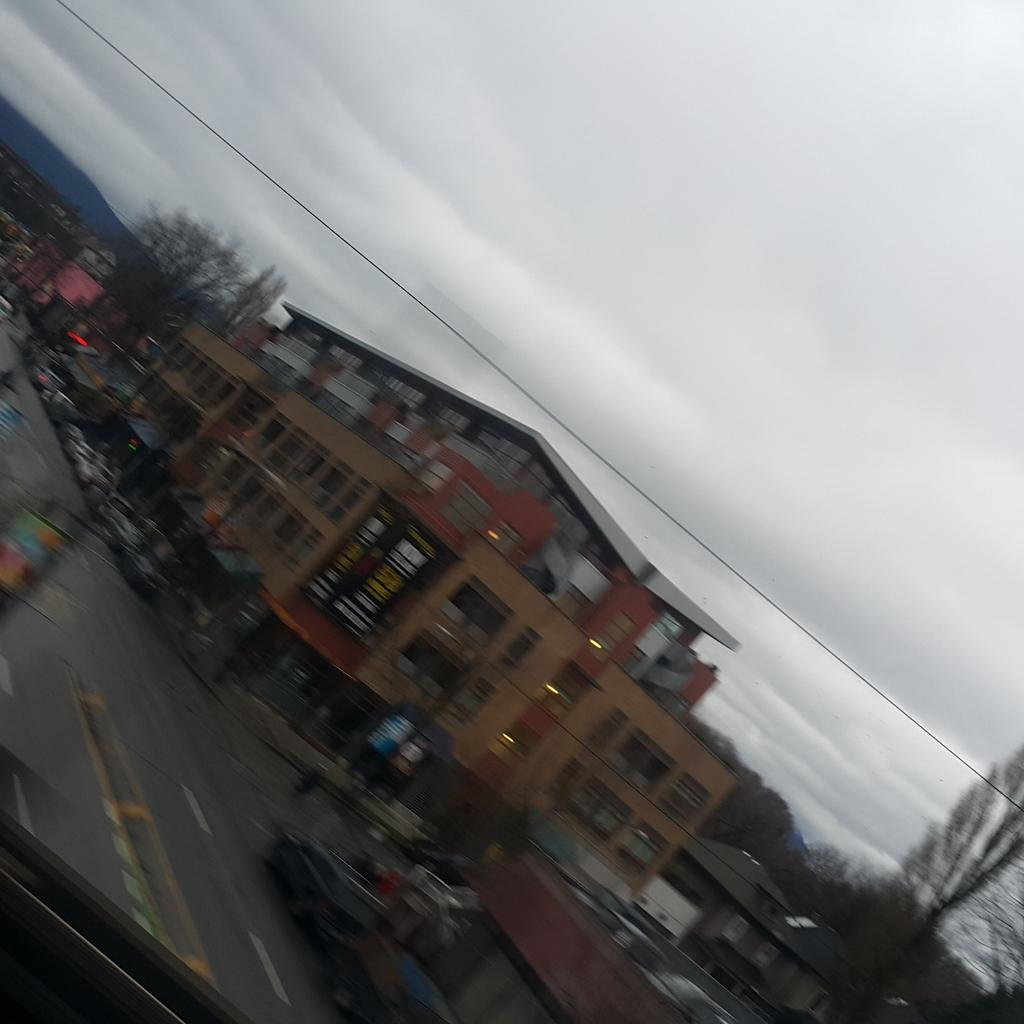What type of structures can be seen in the image? There are buildings in the image. What other natural elements are present in the image? There are trees in the image. What mode of transportation can be seen on the road in the image? There are vehicles on the road in the image. What is attached to the pole in the image? There are boards on a pole in the image. How would you describe the weather in the image? The sky is cloudy in the image. What type of creature is sitting on the rock in the image? There is no rock or creature present in the image. What kind of jewel can be seen on the buildings in the image? There are no jewels present on the buildings in the image. 